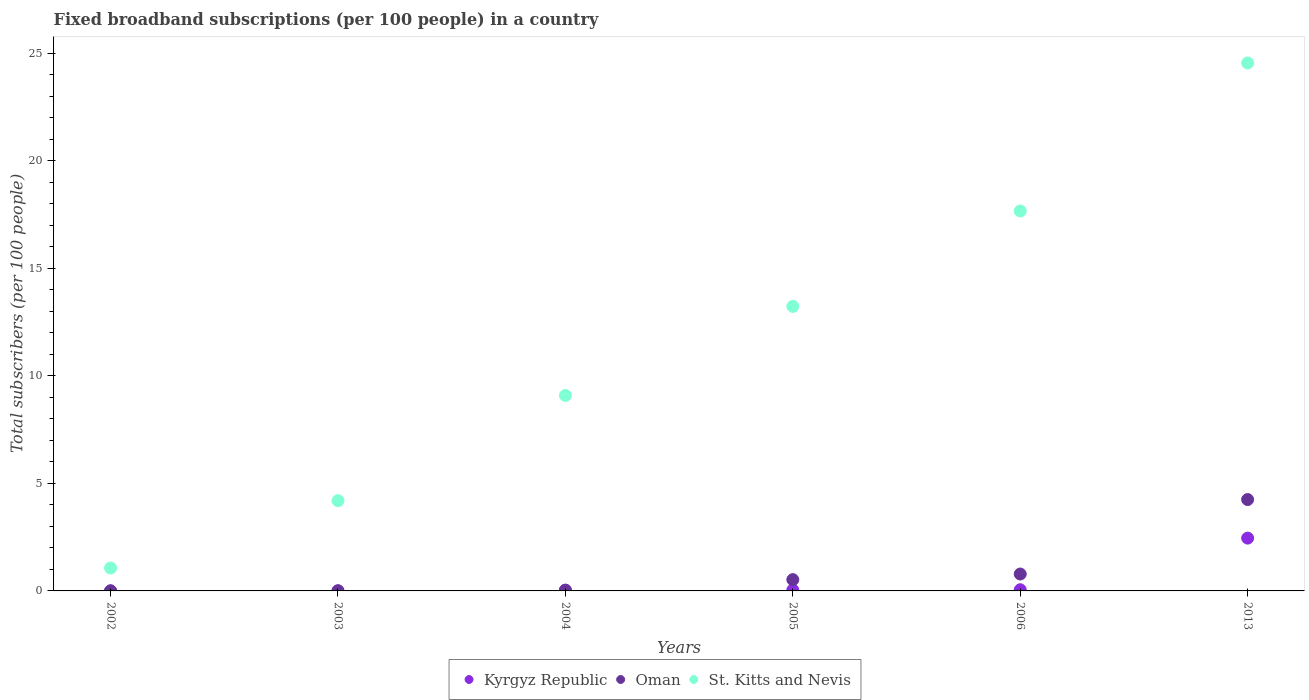How many different coloured dotlines are there?
Ensure brevity in your answer.  3. Is the number of dotlines equal to the number of legend labels?
Make the answer very short. Yes. What is the number of broadband subscriptions in Kyrgyz Republic in 2013?
Offer a terse response. 2.46. Across all years, what is the maximum number of broadband subscriptions in Oman?
Provide a succinct answer. 4.25. Across all years, what is the minimum number of broadband subscriptions in Kyrgyz Republic?
Provide a succinct answer. 0. In which year was the number of broadband subscriptions in Kyrgyz Republic maximum?
Your answer should be compact. 2013. What is the total number of broadband subscriptions in Kyrgyz Republic in the graph?
Ensure brevity in your answer.  2.6. What is the difference between the number of broadband subscriptions in Oman in 2004 and that in 2006?
Provide a succinct answer. -0.76. What is the difference between the number of broadband subscriptions in St. Kitts and Nevis in 2006 and the number of broadband subscriptions in Oman in 2013?
Keep it short and to the point. 13.41. What is the average number of broadband subscriptions in Kyrgyz Republic per year?
Provide a short and direct response. 0.43. In the year 2013, what is the difference between the number of broadband subscriptions in St. Kitts and Nevis and number of broadband subscriptions in Oman?
Keep it short and to the point. 20.3. In how many years, is the number of broadband subscriptions in Kyrgyz Republic greater than 15?
Ensure brevity in your answer.  0. What is the ratio of the number of broadband subscriptions in Kyrgyz Republic in 2002 to that in 2006?
Your answer should be compact. 0.01. What is the difference between the highest and the second highest number of broadband subscriptions in Oman?
Make the answer very short. 3.46. What is the difference between the highest and the lowest number of broadband subscriptions in St. Kitts and Nevis?
Ensure brevity in your answer.  23.48. Is the sum of the number of broadband subscriptions in Oman in 2003 and 2004 greater than the maximum number of broadband subscriptions in Kyrgyz Republic across all years?
Offer a terse response. No. Does the number of broadband subscriptions in Kyrgyz Republic monotonically increase over the years?
Keep it short and to the point. Yes. Is the number of broadband subscriptions in Oman strictly greater than the number of broadband subscriptions in Kyrgyz Republic over the years?
Ensure brevity in your answer.  No. How many dotlines are there?
Your answer should be compact. 3. How many years are there in the graph?
Make the answer very short. 6. Does the graph contain any zero values?
Provide a succinct answer. No. Where does the legend appear in the graph?
Provide a succinct answer. Bottom center. What is the title of the graph?
Ensure brevity in your answer.  Fixed broadband subscriptions (per 100 people) in a country. Does "Israel" appear as one of the legend labels in the graph?
Offer a terse response. No. What is the label or title of the Y-axis?
Keep it short and to the point. Total subscribers (per 100 people). What is the Total subscribers (per 100 people) of Kyrgyz Republic in 2002?
Keep it short and to the point. 0. What is the Total subscribers (per 100 people) of Oman in 2002?
Make the answer very short. 0. What is the Total subscribers (per 100 people) of St. Kitts and Nevis in 2002?
Give a very brief answer. 1.07. What is the Total subscribers (per 100 people) of Kyrgyz Republic in 2003?
Give a very brief answer. 0. What is the Total subscribers (per 100 people) in Oman in 2003?
Provide a succinct answer. 0.01. What is the Total subscribers (per 100 people) in St. Kitts and Nevis in 2003?
Give a very brief answer. 4.19. What is the Total subscribers (per 100 people) in Kyrgyz Republic in 2004?
Provide a succinct answer. 0.04. What is the Total subscribers (per 100 people) in Oman in 2004?
Your answer should be very brief. 0.03. What is the Total subscribers (per 100 people) of St. Kitts and Nevis in 2004?
Give a very brief answer. 9.09. What is the Total subscribers (per 100 people) in Kyrgyz Republic in 2005?
Provide a succinct answer. 0.05. What is the Total subscribers (per 100 people) in Oman in 2005?
Your response must be concise. 0.52. What is the Total subscribers (per 100 people) in St. Kitts and Nevis in 2005?
Offer a terse response. 13.23. What is the Total subscribers (per 100 people) of Kyrgyz Republic in 2006?
Give a very brief answer. 0.05. What is the Total subscribers (per 100 people) in Oman in 2006?
Offer a terse response. 0.79. What is the Total subscribers (per 100 people) of St. Kitts and Nevis in 2006?
Offer a terse response. 17.66. What is the Total subscribers (per 100 people) of Kyrgyz Republic in 2013?
Offer a very short reply. 2.46. What is the Total subscribers (per 100 people) of Oman in 2013?
Ensure brevity in your answer.  4.25. What is the Total subscribers (per 100 people) in St. Kitts and Nevis in 2013?
Make the answer very short. 24.54. Across all years, what is the maximum Total subscribers (per 100 people) of Kyrgyz Republic?
Offer a terse response. 2.46. Across all years, what is the maximum Total subscribers (per 100 people) in Oman?
Provide a succinct answer. 4.25. Across all years, what is the maximum Total subscribers (per 100 people) in St. Kitts and Nevis?
Provide a short and direct response. 24.54. Across all years, what is the minimum Total subscribers (per 100 people) in Kyrgyz Republic?
Provide a succinct answer. 0. Across all years, what is the minimum Total subscribers (per 100 people) of Oman?
Give a very brief answer. 0. Across all years, what is the minimum Total subscribers (per 100 people) in St. Kitts and Nevis?
Keep it short and to the point. 1.07. What is the total Total subscribers (per 100 people) in Kyrgyz Republic in the graph?
Your response must be concise. 2.6. What is the total Total subscribers (per 100 people) of Oman in the graph?
Your response must be concise. 5.59. What is the total Total subscribers (per 100 people) of St. Kitts and Nevis in the graph?
Provide a short and direct response. 69.78. What is the difference between the Total subscribers (per 100 people) of Kyrgyz Republic in 2002 and that in 2003?
Your answer should be compact. -0. What is the difference between the Total subscribers (per 100 people) of Oman in 2002 and that in 2003?
Provide a short and direct response. -0. What is the difference between the Total subscribers (per 100 people) in St. Kitts and Nevis in 2002 and that in 2003?
Your answer should be compact. -3.13. What is the difference between the Total subscribers (per 100 people) in Kyrgyz Republic in 2002 and that in 2004?
Your answer should be compact. -0.04. What is the difference between the Total subscribers (per 100 people) of Oman in 2002 and that in 2004?
Your response must be concise. -0.02. What is the difference between the Total subscribers (per 100 people) in St. Kitts and Nevis in 2002 and that in 2004?
Make the answer very short. -8.02. What is the difference between the Total subscribers (per 100 people) in Kyrgyz Republic in 2002 and that in 2005?
Make the answer very short. -0.04. What is the difference between the Total subscribers (per 100 people) in Oman in 2002 and that in 2005?
Provide a succinct answer. -0.52. What is the difference between the Total subscribers (per 100 people) in St. Kitts and Nevis in 2002 and that in 2005?
Offer a terse response. -12.16. What is the difference between the Total subscribers (per 100 people) in Kyrgyz Republic in 2002 and that in 2006?
Your answer should be very brief. -0.05. What is the difference between the Total subscribers (per 100 people) in Oman in 2002 and that in 2006?
Give a very brief answer. -0.78. What is the difference between the Total subscribers (per 100 people) of St. Kitts and Nevis in 2002 and that in 2006?
Give a very brief answer. -16.6. What is the difference between the Total subscribers (per 100 people) of Kyrgyz Republic in 2002 and that in 2013?
Keep it short and to the point. -2.45. What is the difference between the Total subscribers (per 100 people) of Oman in 2002 and that in 2013?
Your answer should be compact. -4.24. What is the difference between the Total subscribers (per 100 people) of St. Kitts and Nevis in 2002 and that in 2013?
Ensure brevity in your answer.  -23.48. What is the difference between the Total subscribers (per 100 people) in Kyrgyz Republic in 2003 and that in 2004?
Make the answer very short. -0.04. What is the difference between the Total subscribers (per 100 people) in Oman in 2003 and that in 2004?
Offer a very short reply. -0.02. What is the difference between the Total subscribers (per 100 people) of St. Kitts and Nevis in 2003 and that in 2004?
Offer a very short reply. -4.89. What is the difference between the Total subscribers (per 100 people) in Kyrgyz Republic in 2003 and that in 2005?
Offer a very short reply. -0.04. What is the difference between the Total subscribers (per 100 people) of Oman in 2003 and that in 2005?
Give a very brief answer. -0.52. What is the difference between the Total subscribers (per 100 people) of St. Kitts and Nevis in 2003 and that in 2005?
Your answer should be compact. -9.03. What is the difference between the Total subscribers (per 100 people) in Kyrgyz Republic in 2003 and that in 2006?
Your answer should be very brief. -0.05. What is the difference between the Total subscribers (per 100 people) in Oman in 2003 and that in 2006?
Give a very brief answer. -0.78. What is the difference between the Total subscribers (per 100 people) in St. Kitts and Nevis in 2003 and that in 2006?
Make the answer very short. -13.47. What is the difference between the Total subscribers (per 100 people) in Kyrgyz Republic in 2003 and that in 2013?
Your response must be concise. -2.45. What is the difference between the Total subscribers (per 100 people) in Oman in 2003 and that in 2013?
Offer a very short reply. -4.24. What is the difference between the Total subscribers (per 100 people) in St. Kitts and Nevis in 2003 and that in 2013?
Your answer should be compact. -20.35. What is the difference between the Total subscribers (per 100 people) of Kyrgyz Republic in 2004 and that in 2005?
Provide a succinct answer. -0.01. What is the difference between the Total subscribers (per 100 people) in Oman in 2004 and that in 2005?
Make the answer very short. -0.5. What is the difference between the Total subscribers (per 100 people) of St. Kitts and Nevis in 2004 and that in 2005?
Offer a very short reply. -4.14. What is the difference between the Total subscribers (per 100 people) in Kyrgyz Republic in 2004 and that in 2006?
Your response must be concise. -0.02. What is the difference between the Total subscribers (per 100 people) in Oman in 2004 and that in 2006?
Your answer should be very brief. -0.76. What is the difference between the Total subscribers (per 100 people) in St. Kitts and Nevis in 2004 and that in 2006?
Keep it short and to the point. -8.58. What is the difference between the Total subscribers (per 100 people) in Kyrgyz Republic in 2004 and that in 2013?
Keep it short and to the point. -2.42. What is the difference between the Total subscribers (per 100 people) in Oman in 2004 and that in 2013?
Make the answer very short. -4.22. What is the difference between the Total subscribers (per 100 people) of St. Kitts and Nevis in 2004 and that in 2013?
Provide a short and direct response. -15.46. What is the difference between the Total subscribers (per 100 people) in Kyrgyz Republic in 2005 and that in 2006?
Provide a succinct answer. -0.01. What is the difference between the Total subscribers (per 100 people) in Oman in 2005 and that in 2006?
Provide a short and direct response. -0.26. What is the difference between the Total subscribers (per 100 people) of St. Kitts and Nevis in 2005 and that in 2006?
Ensure brevity in your answer.  -4.43. What is the difference between the Total subscribers (per 100 people) of Kyrgyz Republic in 2005 and that in 2013?
Keep it short and to the point. -2.41. What is the difference between the Total subscribers (per 100 people) in Oman in 2005 and that in 2013?
Ensure brevity in your answer.  -3.72. What is the difference between the Total subscribers (per 100 people) in St. Kitts and Nevis in 2005 and that in 2013?
Your answer should be compact. -11.31. What is the difference between the Total subscribers (per 100 people) in Kyrgyz Republic in 2006 and that in 2013?
Your answer should be compact. -2.4. What is the difference between the Total subscribers (per 100 people) in Oman in 2006 and that in 2013?
Provide a short and direct response. -3.46. What is the difference between the Total subscribers (per 100 people) of St. Kitts and Nevis in 2006 and that in 2013?
Your answer should be very brief. -6.88. What is the difference between the Total subscribers (per 100 people) in Kyrgyz Republic in 2002 and the Total subscribers (per 100 people) in Oman in 2003?
Offer a very short reply. -0.01. What is the difference between the Total subscribers (per 100 people) of Kyrgyz Republic in 2002 and the Total subscribers (per 100 people) of St. Kitts and Nevis in 2003?
Your answer should be very brief. -4.19. What is the difference between the Total subscribers (per 100 people) in Oman in 2002 and the Total subscribers (per 100 people) in St. Kitts and Nevis in 2003?
Your response must be concise. -4.19. What is the difference between the Total subscribers (per 100 people) of Kyrgyz Republic in 2002 and the Total subscribers (per 100 people) of Oman in 2004?
Offer a terse response. -0.03. What is the difference between the Total subscribers (per 100 people) in Kyrgyz Republic in 2002 and the Total subscribers (per 100 people) in St. Kitts and Nevis in 2004?
Make the answer very short. -9.09. What is the difference between the Total subscribers (per 100 people) of Oman in 2002 and the Total subscribers (per 100 people) of St. Kitts and Nevis in 2004?
Your answer should be very brief. -9.08. What is the difference between the Total subscribers (per 100 people) in Kyrgyz Republic in 2002 and the Total subscribers (per 100 people) in Oman in 2005?
Your answer should be very brief. -0.52. What is the difference between the Total subscribers (per 100 people) in Kyrgyz Republic in 2002 and the Total subscribers (per 100 people) in St. Kitts and Nevis in 2005?
Offer a terse response. -13.23. What is the difference between the Total subscribers (per 100 people) of Oman in 2002 and the Total subscribers (per 100 people) of St. Kitts and Nevis in 2005?
Keep it short and to the point. -13.22. What is the difference between the Total subscribers (per 100 people) in Kyrgyz Republic in 2002 and the Total subscribers (per 100 people) in Oman in 2006?
Give a very brief answer. -0.78. What is the difference between the Total subscribers (per 100 people) of Kyrgyz Republic in 2002 and the Total subscribers (per 100 people) of St. Kitts and Nevis in 2006?
Your response must be concise. -17.66. What is the difference between the Total subscribers (per 100 people) in Oman in 2002 and the Total subscribers (per 100 people) in St. Kitts and Nevis in 2006?
Your answer should be compact. -17.66. What is the difference between the Total subscribers (per 100 people) in Kyrgyz Republic in 2002 and the Total subscribers (per 100 people) in Oman in 2013?
Keep it short and to the point. -4.25. What is the difference between the Total subscribers (per 100 people) of Kyrgyz Republic in 2002 and the Total subscribers (per 100 people) of St. Kitts and Nevis in 2013?
Make the answer very short. -24.54. What is the difference between the Total subscribers (per 100 people) in Oman in 2002 and the Total subscribers (per 100 people) in St. Kitts and Nevis in 2013?
Keep it short and to the point. -24.54. What is the difference between the Total subscribers (per 100 people) of Kyrgyz Republic in 2003 and the Total subscribers (per 100 people) of Oman in 2004?
Ensure brevity in your answer.  -0.02. What is the difference between the Total subscribers (per 100 people) of Kyrgyz Republic in 2003 and the Total subscribers (per 100 people) of St. Kitts and Nevis in 2004?
Ensure brevity in your answer.  -9.08. What is the difference between the Total subscribers (per 100 people) in Oman in 2003 and the Total subscribers (per 100 people) in St. Kitts and Nevis in 2004?
Ensure brevity in your answer.  -9.08. What is the difference between the Total subscribers (per 100 people) of Kyrgyz Republic in 2003 and the Total subscribers (per 100 people) of Oman in 2005?
Offer a terse response. -0.52. What is the difference between the Total subscribers (per 100 people) of Kyrgyz Republic in 2003 and the Total subscribers (per 100 people) of St. Kitts and Nevis in 2005?
Your response must be concise. -13.22. What is the difference between the Total subscribers (per 100 people) in Oman in 2003 and the Total subscribers (per 100 people) in St. Kitts and Nevis in 2005?
Ensure brevity in your answer.  -13.22. What is the difference between the Total subscribers (per 100 people) in Kyrgyz Republic in 2003 and the Total subscribers (per 100 people) in Oman in 2006?
Your answer should be very brief. -0.78. What is the difference between the Total subscribers (per 100 people) of Kyrgyz Republic in 2003 and the Total subscribers (per 100 people) of St. Kitts and Nevis in 2006?
Offer a very short reply. -17.66. What is the difference between the Total subscribers (per 100 people) in Oman in 2003 and the Total subscribers (per 100 people) in St. Kitts and Nevis in 2006?
Give a very brief answer. -17.66. What is the difference between the Total subscribers (per 100 people) of Kyrgyz Republic in 2003 and the Total subscribers (per 100 people) of Oman in 2013?
Your response must be concise. -4.24. What is the difference between the Total subscribers (per 100 people) in Kyrgyz Republic in 2003 and the Total subscribers (per 100 people) in St. Kitts and Nevis in 2013?
Give a very brief answer. -24.54. What is the difference between the Total subscribers (per 100 people) in Oman in 2003 and the Total subscribers (per 100 people) in St. Kitts and Nevis in 2013?
Your answer should be compact. -24.54. What is the difference between the Total subscribers (per 100 people) of Kyrgyz Republic in 2004 and the Total subscribers (per 100 people) of Oman in 2005?
Provide a succinct answer. -0.49. What is the difference between the Total subscribers (per 100 people) of Kyrgyz Republic in 2004 and the Total subscribers (per 100 people) of St. Kitts and Nevis in 2005?
Keep it short and to the point. -13.19. What is the difference between the Total subscribers (per 100 people) of Oman in 2004 and the Total subscribers (per 100 people) of St. Kitts and Nevis in 2005?
Provide a short and direct response. -13.2. What is the difference between the Total subscribers (per 100 people) of Kyrgyz Republic in 2004 and the Total subscribers (per 100 people) of Oman in 2006?
Your answer should be compact. -0.75. What is the difference between the Total subscribers (per 100 people) of Kyrgyz Republic in 2004 and the Total subscribers (per 100 people) of St. Kitts and Nevis in 2006?
Your answer should be compact. -17.62. What is the difference between the Total subscribers (per 100 people) in Oman in 2004 and the Total subscribers (per 100 people) in St. Kitts and Nevis in 2006?
Offer a very short reply. -17.64. What is the difference between the Total subscribers (per 100 people) of Kyrgyz Republic in 2004 and the Total subscribers (per 100 people) of Oman in 2013?
Keep it short and to the point. -4.21. What is the difference between the Total subscribers (per 100 people) in Kyrgyz Republic in 2004 and the Total subscribers (per 100 people) in St. Kitts and Nevis in 2013?
Keep it short and to the point. -24.5. What is the difference between the Total subscribers (per 100 people) in Oman in 2004 and the Total subscribers (per 100 people) in St. Kitts and Nevis in 2013?
Your response must be concise. -24.52. What is the difference between the Total subscribers (per 100 people) in Kyrgyz Republic in 2005 and the Total subscribers (per 100 people) in Oman in 2006?
Make the answer very short. -0.74. What is the difference between the Total subscribers (per 100 people) in Kyrgyz Republic in 2005 and the Total subscribers (per 100 people) in St. Kitts and Nevis in 2006?
Give a very brief answer. -17.62. What is the difference between the Total subscribers (per 100 people) of Oman in 2005 and the Total subscribers (per 100 people) of St. Kitts and Nevis in 2006?
Provide a short and direct response. -17.14. What is the difference between the Total subscribers (per 100 people) of Kyrgyz Republic in 2005 and the Total subscribers (per 100 people) of Oman in 2013?
Make the answer very short. -4.2. What is the difference between the Total subscribers (per 100 people) in Kyrgyz Republic in 2005 and the Total subscribers (per 100 people) in St. Kitts and Nevis in 2013?
Your answer should be very brief. -24.5. What is the difference between the Total subscribers (per 100 people) of Oman in 2005 and the Total subscribers (per 100 people) of St. Kitts and Nevis in 2013?
Your response must be concise. -24.02. What is the difference between the Total subscribers (per 100 people) in Kyrgyz Republic in 2006 and the Total subscribers (per 100 people) in Oman in 2013?
Make the answer very short. -4.19. What is the difference between the Total subscribers (per 100 people) of Kyrgyz Republic in 2006 and the Total subscribers (per 100 people) of St. Kitts and Nevis in 2013?
Offer a very short reply. -24.49. What is the difference between the Total subscribers (per 100 people) in Oman in 2006 and the Total subscribers (per 100 people) in St. Kitts and Nevis in 2013?
Give a very brief answer. -23.76. What is the average Total subscribers (per 100 people) in Kyrgyz Republic per year?
Your answer should be compact. 0.43. What is the average Total subscribers (per 100 people) in Oman per year?
Your answer should be very brief. 0.93. What is the average Total subscribers (per 100 people) in St. Kitts and Nevis per year?
Provide a short and direct response. 11.63. In the year 2002, what is the difference between the Total subscribers (per 100 people) of Kyrgyz Republic and Total subscribers (per 100 people) of Oman?
Offer a very short reply. -0. In the year 2002, what is the difference between the Total subscribers (per 100 people) of Kyrgyz Republic and Total subscribers (per 100 people) of St. Kitts and Nevis?
Your response must be concise. -1.06. In the year 2002, what is the difference between the Total subscribers (per 100 people) in Oman and Total subscribers (per 100 people) in St. Kitts and Nevis?
Offer a terse response. -1.06. In the year 2003, what is the difference between the Total subscribers (per 100 people) in Kyrgyz Republic and Total subscribers (per 100 people) in Oman?
Provide a short and direct response. -0. In the year 2003, what is the difference between the Total subscribers (per 100 people) of Kyrgyz Republic and Total subscribers (per 100 people) of St. Kitts and Nevis?
Your answer should be compact. -4.19. In the year 2003, what is the difference between the Total subscribers (per 100 people) in Oman and Total subscribers (per 100 people) in St. Kitts and Nevis?
Give a very brief answer. -4.19. In the year 2004, what is the difference between the Total subscribers (per 100 people) in Kyrgyz Republic and Total subscribers (per 100 people) in Oman?
Keep it short and to the point. 0.01. In the year 2004, what is the difference between the Total subscribers (per 100 people) of Kyrgyz Republic and Total subscribers (per 100 people) of St. Kitts and Nevis?
Your answer should be very brief. -9.05. In the year 2004, what is the difference between the Total subscribers (per 100 people) of Oman and Total subscribers (per 100 people) of St. Kitts and Nevis?
Ensure brevity in your answer.  -9.06. In the year 2005, what is the difference between the Total subscribers (per 100 people) in Kyrgyz Republic and Total subscribers (per 100 people) in Oman?
Your answer should be very brief. -0.48. In the year 2005, what is the difference between the Total subscribers (per 100 people) of Kyrgyz Republic and Total subscribers (per 100 people) of St. Kitts and Nevis?
Keep it short and to the point. -13.18. In the year 2005, what is the difference between the Total subscribers (per 100 people) in Oman and Total subscribers (per 100 people) in St. Kitts and Nevis?
Your response must be concise. -12.7. In the year 2006, what is the difference between the Total subscribers (per 100 people) in Kyrgyz Republic and Total subscribers (per 100 people) in Oman?
Make the answer very short. -0.73. In the year 2006, what is the difference between the Total subscribers (per 100 people) of Kyrgyz Republic and Total subscribers (per 100 people) of St. Kitts and Nevis?
Make the answer very short. -17.61. In the year 2006, what is the difference between the Total subscribers (per 100 people) of Oman and Total subscribers (per 100 people) of St. Kitts and Nevis?
Make the answer very short. -16.88. In the year 2013, what is the difference between the Total subscribers (per 100 people) in Kyrgyz Republic and Total subscribers (per 100 people) in Oman?
Provide a short and direct response. -1.79. In the year 2013, what is the difference between the Total subscribers (per 100 people) in Kyrgyz Republic and Total subscribers (per 100 people) in St. Kitts and Nevis?
Ensure brevity in your answer.  -22.09. In the year 2013, what is the difference between the Total subscribers (per 100 people) in Oman and Total subscribers (per 100 people) in St. Kitts and Nevis?
Provide a short and direct response. -20.3. What is the ratio of the Total subscribers (per 100 people) in Kyrgyz Republic in 2002 to that in 2003?
Provide a short and direct response. 0.26. What is the ratio of the Total subscribers (per 100 people) in Oman in 2002 to that in 2003?
Provide a short and direct response. 0.74. What is the ratio of the Total subscribers (per 100 people) in St. Kitts and Nevis in 2002 to that in 2003?
Your response must be concise. 0.25. What is the ratio of the Total subscribers (per 100 people) in Kyrgyz Republic in 2002 to that in 2004?
Offer a very short reply. 0.02. What is the ratio of the Total subscribers (per 100 people) of Oman in 2002 to that in 2004?
Give a very brief answer. 0.15. What is the ratio of the Total subscribers (per 100 people) of St. Kitts and Nevis in 2002 to that in 2004?
Ensure brevity in your answer.  0.12. What is the ratio of the Total subscribers (per 100 people) in Kyrgyz Republic in 2002 to that in 2005?
Provide a short and direct response. 0.02. What is the ratio of the Total subscribers (per 100 people) in Oman in 2002 to that in 2005?
Provide a succinct answer. 0.01. What is the ratio of the Total subscribers (per 100 people) in St. Kitts and Nevis in 2002 to that in 2005?
Your response must be concise. 0.08. What is the ratio of the Total subscribers (per 100 people) of Kyrgyz Republic in 2002 to that in 2006?
Offer a terse response. 0.01. What is the ratio of the Total subscribers (per 100 people) of Oman in 2002 to that in 2006?
Keep it short and to the point. 0.01. What is the ratio of the Total subscribers (per 100 people) of St. Kitts and Nevis in 2002 to that in 2006?
Your answer should be compact. 0.06. What is the ratio of the Total subscribers (per 100 people) in Oman in 2002 to that in 2013?
Make the answer very short. 0. What is the ratio of the Total subscribers (per 100 people) in St. Kitts and Nevis in 2002 to that in 2013?
Provide a short and direct response. 0.04. What is the ratio of the Total subscribers (per 100 people) in Kyrgyz Republic in 2003 to that in 2004?
Provide a short and direct response. 0.07. What is the ratio of the Total subscribers (per 100 people) of Oman in 2003 to that in 2004?
Offer a terse response. 0.21. What is the ratio of the Total subscribers (per 100 people) of St. Kitts and Nevis in 2003 to that in 2004?
Offer a very short reply. 0.46. What is the ratio of the Total subscribers (per 100 people) of Kyrgyz Republic in 2003 to that in 2005?
Offer a terse response. 0.06. What is the ratio of the Total subscribers (per 100 people) of Oman in 2003 to that in 2005?
Ensure brevity in your answer.  0.01. What is the ratio of the Total subscribers (per 100 people) in St. Kitts and Nevis in 2003 to that in 2005?
Offer a very short reply. 0.32. What is the ratio of the Total subscribers (per 100 people) of Kyrgyz Republic in 2003 to that in 2006?
Your response must be concise. 0.05. What is the ratio of the Total subscribers (per 100 people) in Oman in 2003 to that in 2006?
Offer a terse response. 0.01. What is the ratio of the Total subscribers (per 100 people) of St. Kitts and Nevis in 2003 to that in 2006?
Make the answer very short. 0.24. What is the ratio of the Total subscribers (per 100 people) in Kyrgyz Republic in 2003 to that in 2013?
Offer a very short reply. 0. What is the ratio of the Total subscribers (per 100 people) of Oman in 2003 to that in 2013?
Your answer should be compact. 0. What is the ratio of the Total subscribers (per 100 people) of St. Kitts and Nevis in 2003 to that in 2013?
Your answer should be compact. 0.17. What is the ratio of the Total subscribers (per 100 people) in Kyrgyz Republic in 2004 to that in 2005?
Your response must be concise. 0.84. What is the ratio of the Total subscribers (per 100 people) of Oman in 2004 to that in 2005?
Provide a short and direct response. 0.05. What is the ratio of the Total subscribers (per 100 people) in St. Kitts and Nevis in 2004 to that in 2005?
Give a very brief answer. 0.69. What is the ratio of the Total subscribers (per 100 people) in Kyrgyz Republic in 2004 to that in 2006?
Make the answer very short. 0.7. What is the ratio of the Total subscribers (per 100 people) of Oman in 2004 to that in 2006?
Your answer should be very brief. 0.03. What is the ratio of the Total subscribers (per 100 people) in St. Kitts and Nevis in 2004 to that in 2006?
Offer a very short reply. 0.51. What is the ratio of the Total subscribers (per 100 people) in Kyrgyz Republic in 2004 to that in 2013?
Offer a very short reply. 0.02. What is the ratio of the Total subscribers (per 100 people) of Oman in 2004 to that in 2013?
Make the answer very short. 0.01. What is the ratio of the Total subscribers (per 100 people) of St. Kitts and Nevis in 2004 to that in 2013?
Provide a succinct answer. 0.37. What is the ratio of the Total subscribers (per 100 people) of Kyrgyz Republic in 2005 to that in 2006?
Give a very brief answer. 0.84. What is the ratio of the Total subscribers (per 100 people) in Oman in 2005 to that in 2006?
Offer a terse response. 0.67. What is the ratio of the Total subscribers (per 100 people) in St. Kitts and Nevis in 2005 to that in 2006?
Provide a short and direct response. 0.75. What is the ratio of the Total subscribers (per 100 people) in Kyrgyz Republic in 2005 to that in 2013?
Your response must be concise. 0.02. What is the ratio of the Total subscribers (per 100 people) of Oman in 2005 to that in 2013?
Offer a very short reply. 0.12. What is the ratio of the Total subscribers (per 100 people) in St. Kitts and Nevis in 2005 to that in 2013?
Your answer should be very brief. 0.54. What is the ratio of the Total subscribers (per 100 people) in Kyrgyz Republic in 2006 to that in 2013?
Your response must be concise. 0.02. What is the ratio of the Total subscribers (per 100 people) of Oman in 2006 to that in 2013?
Your answer should be compact. 0.18. What is the ratio of the Total subscribers (per 100 people) of St. Kitts and Nevis in 2006 to that in 2013?
Make the answer very short. 0.72. What is the difference between the highest and the second highest Total subscribers (per 100 people) of Kyrgyz Republic?
Keep it short and to the point. 2.4. What is the difference between the highest and the second highest Total subscribers (per 100 people) of Oman?
Offer a very short reply. 3.46. What is the difference between the highest and the second highest Total subscribers (per 100 people) in St. Kitts and Nevis?
Provide a succinct answer. 6.88. What is the difference between the highest and the lowest Total subscribers (per 100 people) of Kyrgyz Republic?
Provide a succinct answer. 2.45. What is the difference between the highest and the lowest Total subscribers (per 100 people) in Oman?
Provide a succinct answer. 4.24. What is the difference between the highest and the lowest Total subscribers (per 100 people) in St. Kitts and Nevis?
Ensure brevity in your answer.  23.48. 